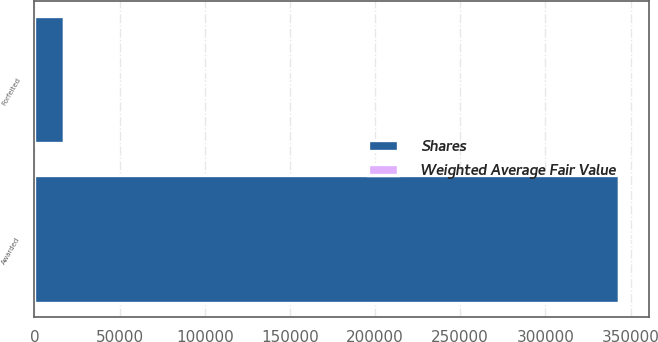<chart> <loc_0><loc_0><loc_500><loc_500><stacked_bar_chart><ecel><fcel>Awarded<fcel>Forfeited<nl><fcel>Shares<fcel>343500<fcel>17438<nl><fcel>Weighted Average Fair Value<fcel>47.56<fcel>48.01<nl></chart> 